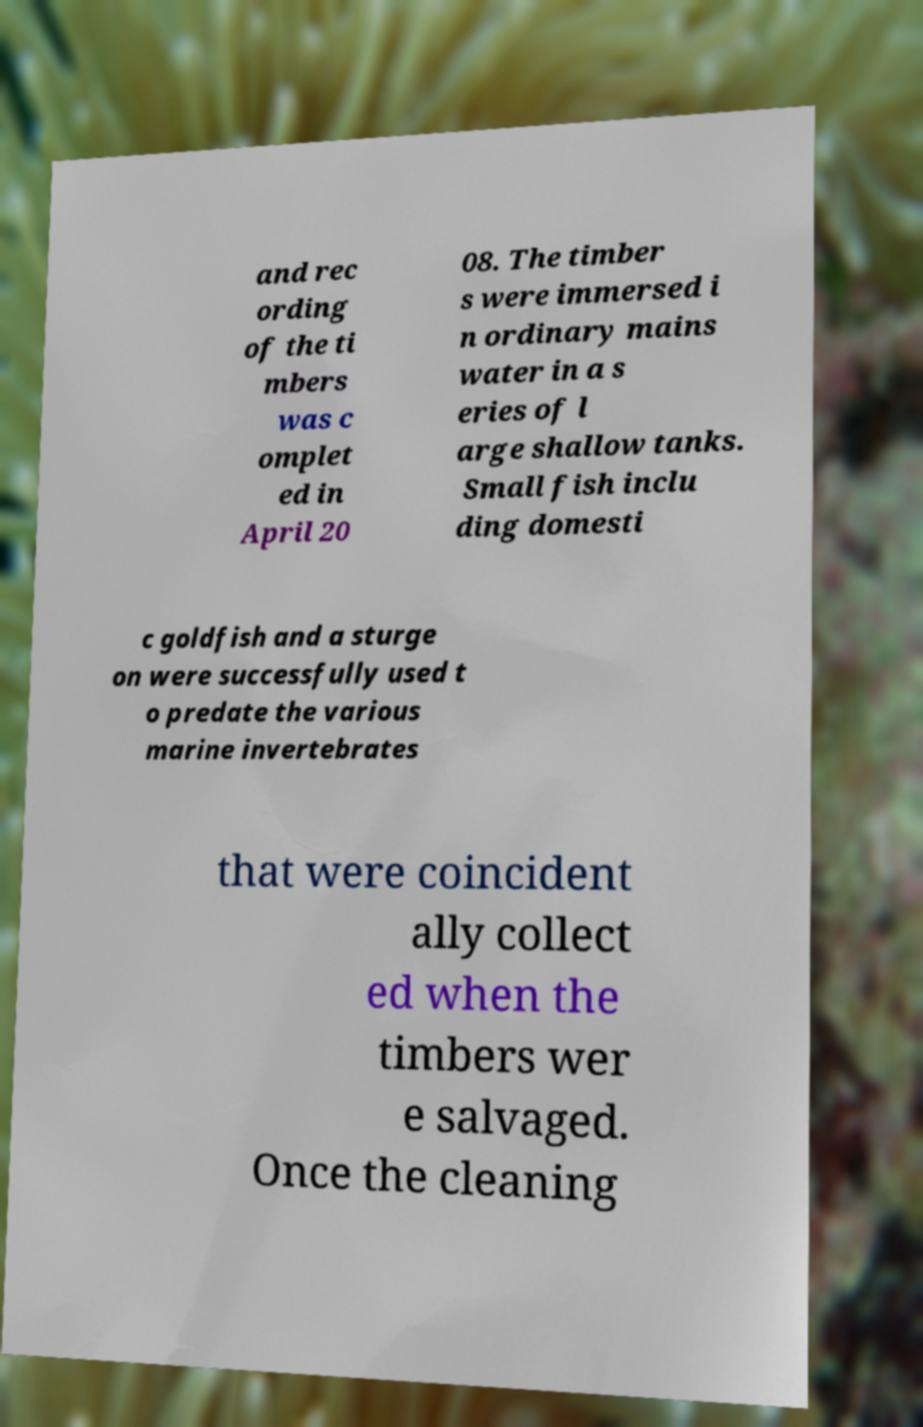Could you assist in decoding the text presented in this image and type it out clearly? and rec ording of the ti mbers was c omplet ed in April 20 08. The timber s were immersed i n ordinary mains water in a s eries of l arge shallow tanks. Small fish inclu ding domesti c goldfish and a sturge on were successfully used t o predate the various marine invertebrates that were coincident ally collect ed when the timbers wer e salvaged. Once the cleaning 